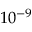Convert formula to latex. <formula><loc_0><loc_0><loc_500><loc_500>1 0 ^ { - 9 }</formula> 